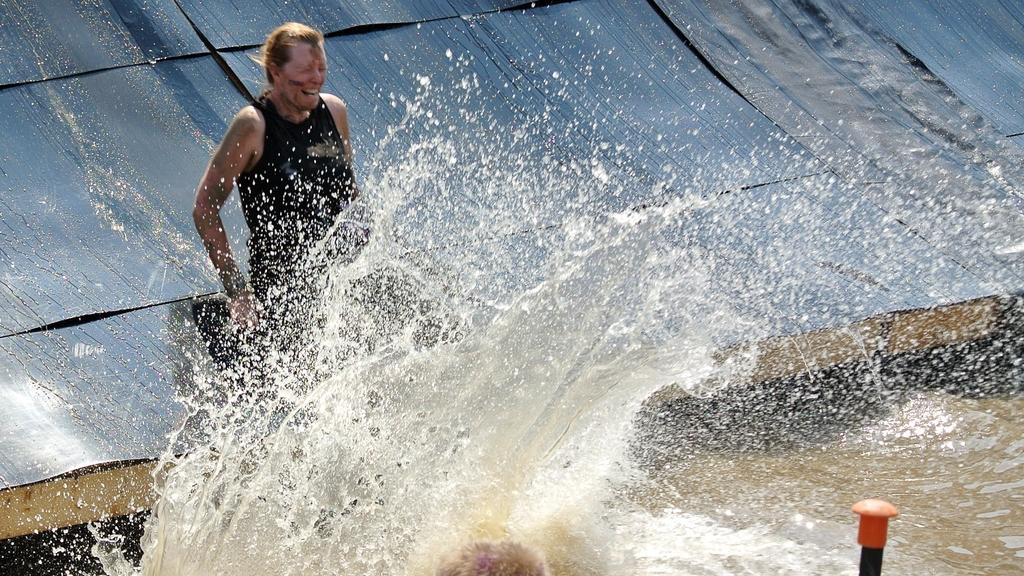What is the main subject of the image? There is a person in the image. What is the person wearing? The person is wearing a black dress. Where is the person located in the image? The person is on a water slide. What can be seen at the bottom of the image? There is water visible at the bottom of the image. What object is present in the image besides the person and water slide? There is a pole present in the image. How does the person pay for the water slide in the image? There is no indication of payment in the image; it only shows the person on the water slide. What idea does the person have while on the water slide in the image? There is no way to determine the person's thoughts or ideas from the image. 